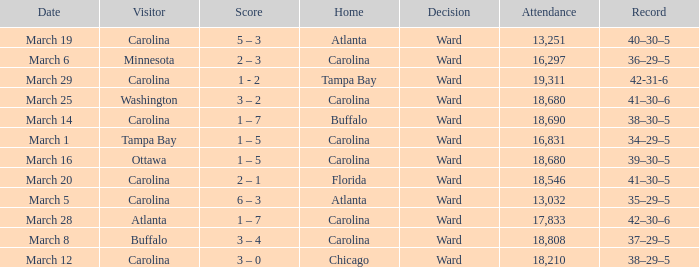What is the Record when Buffalo is at Home? 38–30–5. 